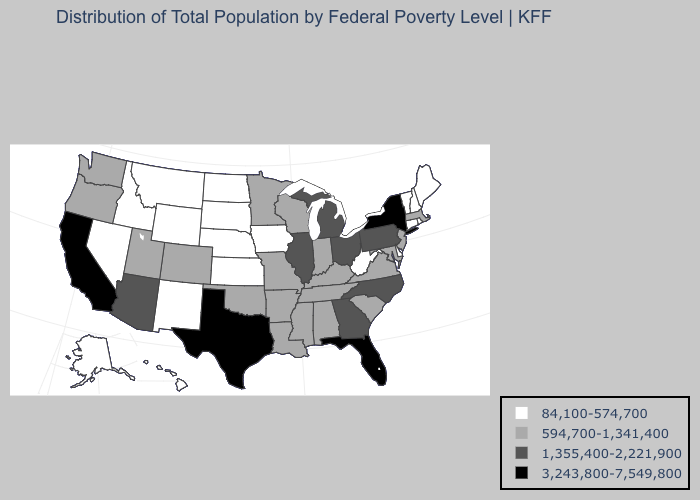Name the states that have a value in the range 594,700-1,341,400?
Quick response, please. Alabama, Arkansas, Colorado, Indiana, Kentucky, Louisiana, Maryland, Massachusetts, Minnesota, Mississippi, Missouri, New Jersey, Oklahoma, Oregon, South Carolina, Tennessee, Utah, Virginia, Washington, Wisconsin. Which states have the highest value in the USA?
Give a very brief answer. California, Florida, New York, Texas. What is the value of Tennessee?
Keep it brief. 594,700-1,341,400. What is the highest value in the South ?
Give a very brief answer. 3,243,800-7,549,800. Among the states that border California , which have the lowest value?
Concise answer only. Nevada. Is the legend a continuous bar?
Short answer required. No. What is the value of Wisconsin?
Write a very short answer. 594,700-1,341,400. Name the states that have a value in the range 84,100-574,700?
Give a very brief answer. Alaska, Connecticut, Delaware, Hawaii, Idaho, Iowa, Kansas, Maine, Montana, Nebraska, Nevada, New Hampshire, New Mexico, North Dakota, Rhode Island, South Dakota, Vermont, West Virginia, Wyoming. Does Wisconsin have the lowest value in the MidWest?
Give a very brief answer. No. Among the states that border Missouri , which have the lowest value?
Keep it brief. Iowa, Kansas, Nebraska. Does Texas have the highest value in the South?
Quick response, please. Yes. What is the value of Kansas?
Write a very short answer. 84,100-574,700. How many symbols are there in the legend?
Give a very brief answer. 4. Name the states that have a value in the range 84,100-574,700?
Keep it brief. Alaska, Connecticut, Delaware, Hawaii, Idaho, Iowa, Kansas, Maine, Montana, Nebraska, Nevada, New Hampshire, New Mexico, North Dakota, Rhode Island, South Dakota, Vermont, West Virginia, Wyoming. Does Massachusetts have the highest value in the USA?
Concise answer only. No. 